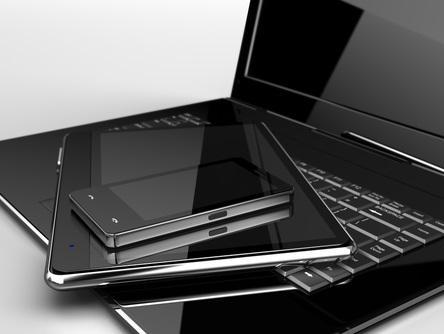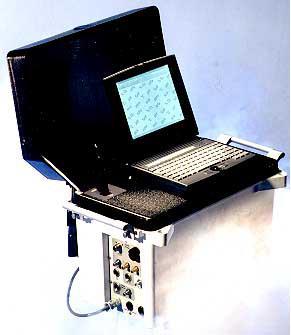The first image is the image on the left, the second image is the image on the right. Assess this claim about the two images: "An open laptop is sitting on a stack of at least three rectangular items in the left image.". Correct or not? Answer yes or no. No. 